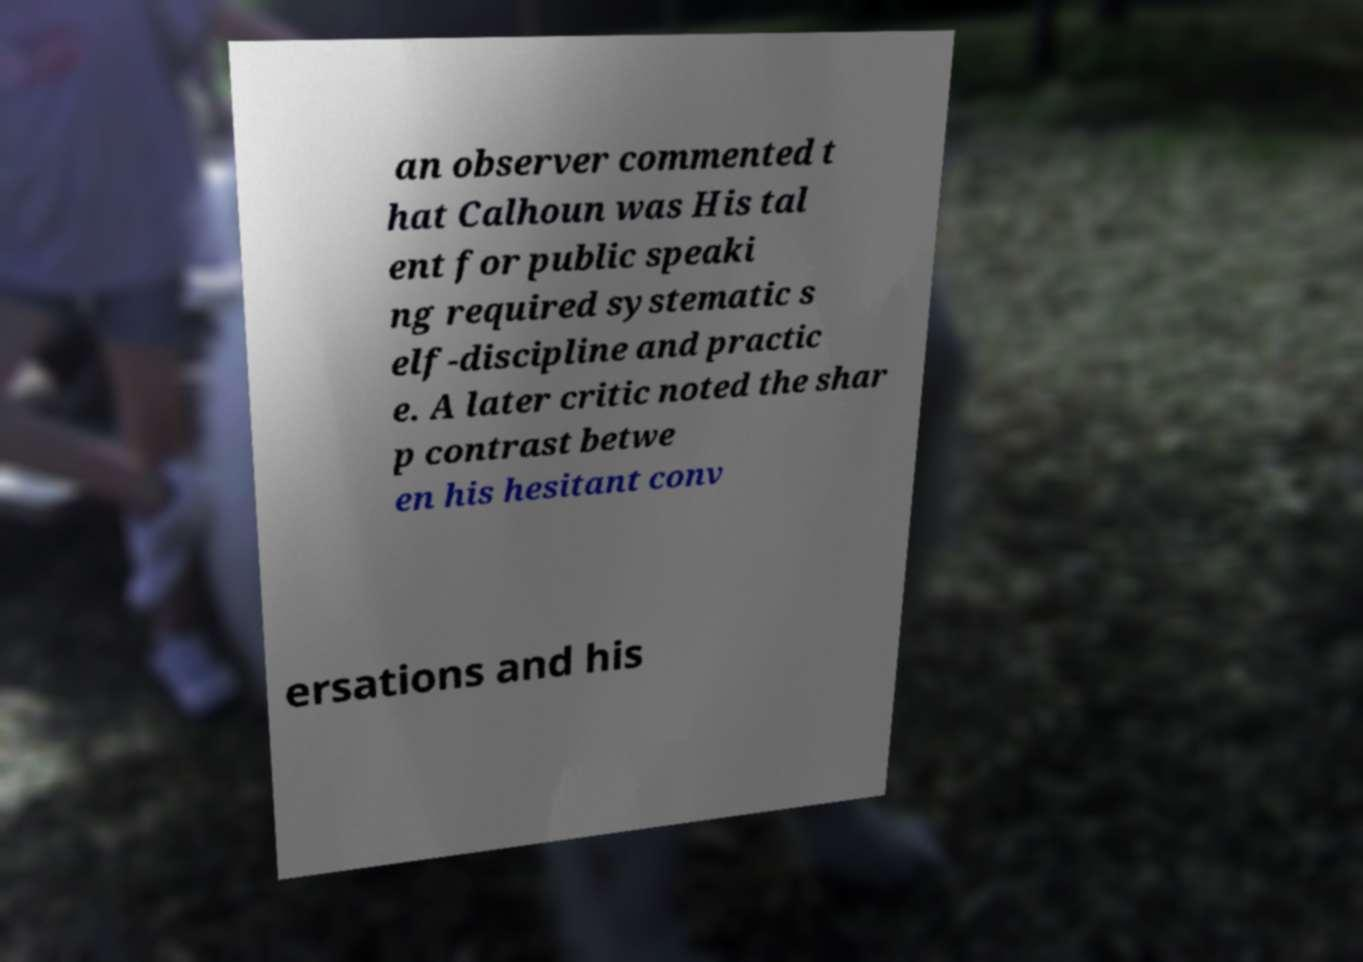Can you accurately transcribe the text from the provided image for me? an observer commented t hat Calhoun was His tal ent for public speaki ng required systematic s elf-discipline and practic e. A later critic noted the shar p contrast betwe en his hesitant conv ersations and his 